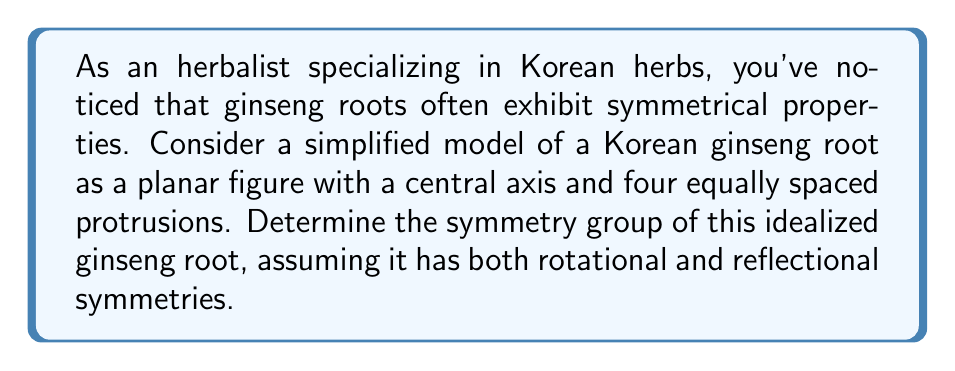Solve this math problem. Let's approach this step-by-step:

1) First, we need to identify the symmetries of the idealized ginseng root:

   a) Rotational symmetries: The root has 4-fold rotational symmetry, meaning it can be rotated by 90°, 180°, 270°, and 360° (which is equivalent to 0°) to return to its original position.

   b) Reflectional symmetries: The root has 4 lines of reflection - one vertical, one horizontal, and two diagonal.

2) These symmetries form a group under composition. Let's identify the elements:
   
   - Identity: e (no rotation or reflection)
   - Rotations: $r_{90}, r_{180}, r_{270}$ (rotations by 90°, 180°, 270° respectively)
   - Reflections: $s_v, s_h, s_{d1}, s_{d2}$ (vertical, horizontal, and two diagonal reflections)

3) The group has 8 elements in total.

4) This group structure is isomorphic to the dihedral group $D_4$, which is the symmetry group of a square.

5) The group can be generated by two elements: a 90° rotation and a reflection. All other elements can be obtained by composing these two.

6) The group operation table would be identical to that of $D_4$.

Therefore, the symmetry group of the idealized Korean ginseng root is isomorphic to $D_4$, the dihedral group of order 8.
Answer: $D_4$ 